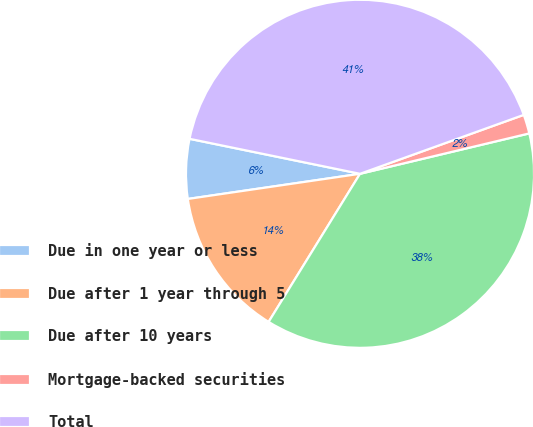Convert chart. <chart><loc_0><loc_0><loc_500><loc_500><pie_chart><fcel>Due in one year or less<fcel>Due after 1 year through 5<fcel>Due after 10 years<fcel>Mortgage-backed securities<fcel>Total<nl><fcel>5.53%<fcel>13.89%<fcel>37.53%<fcel>1.77%<fcel>41.28%<nl></chart> 